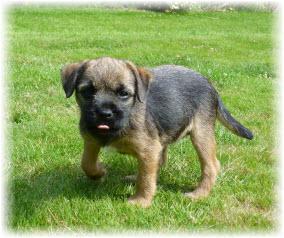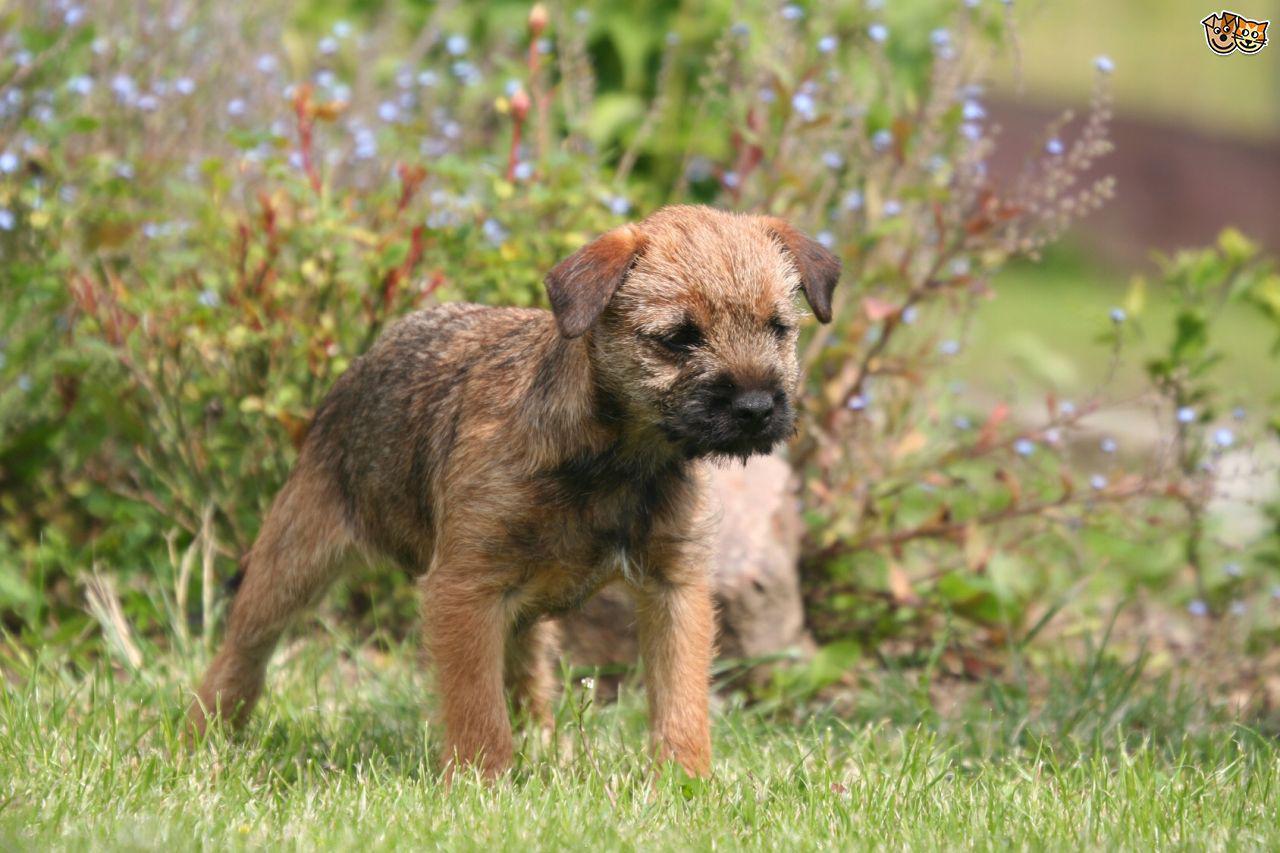The first image is the image on the left, the second image is the image on the right. Assess this claim about the two images: "there is no visible grass". Correct or not? Answer yes or no. No. 